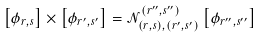Convert formula to latex. <formula><loc_0><loc_0><loc_500><loc_500>\left [ \phi _ { r , s } \right ] \times \left [ \phi _ { r ^ { \prime } , s ^ { \prime } } \right ] = \mathcal { N } _ { ( r , s ) , ( r ^ { \prime } , s ^ { \prime } ) } ^ { ( r ^ { \prime \prime } , s ^ { \prime \prime } ) } \left [ \phi _ { r ^ { \prime \prime } , s ^ { \prime \prime } } \right ]</formula> 